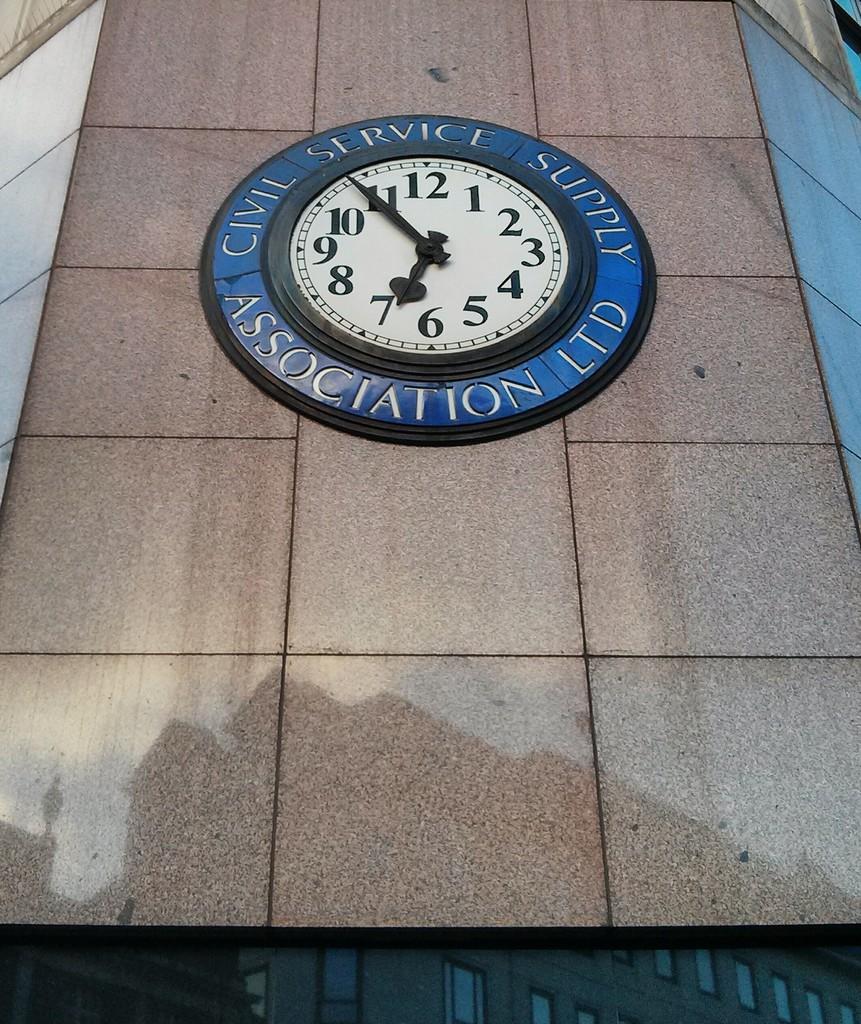What number is the small hand of the clock pointing to?
Provide a succinct answer. 7. What association's building is this clock on?
Provide a short and direct response. Civil service supply. 